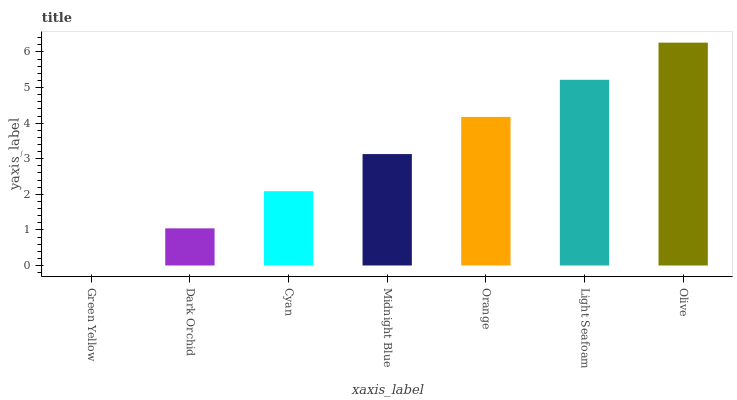Is Green Yellow the minimum?
Answer yes or no. Yes. Is Olive the maximum?
Answer yes or no. Yes. Is Dark Orchid the minimum?
Answer yes or no. No. Is Dark Orchid the maximum?
Answer yes or no. No. Is Dark Orchid greater than Green Yellow?
Answer yes or no. Yes. Is Green Yellow less than Dark Orchid?
Answer yes or no. Yes. Is Green Yellow greater than Dark Orchid?
Answer yes or no. No. Is Dark Orchid less than Green Yellow?
Answer yes or no. No. Is Midnight Blue the high median?
Answer yes or no. Yes. Is Midnight Blue the low median?
Answer yes or no. Yes. Is Green Yellow the high median?
Answer yes or no. No. Is Dark Orchid the low median?
Answer yes or no. No. 